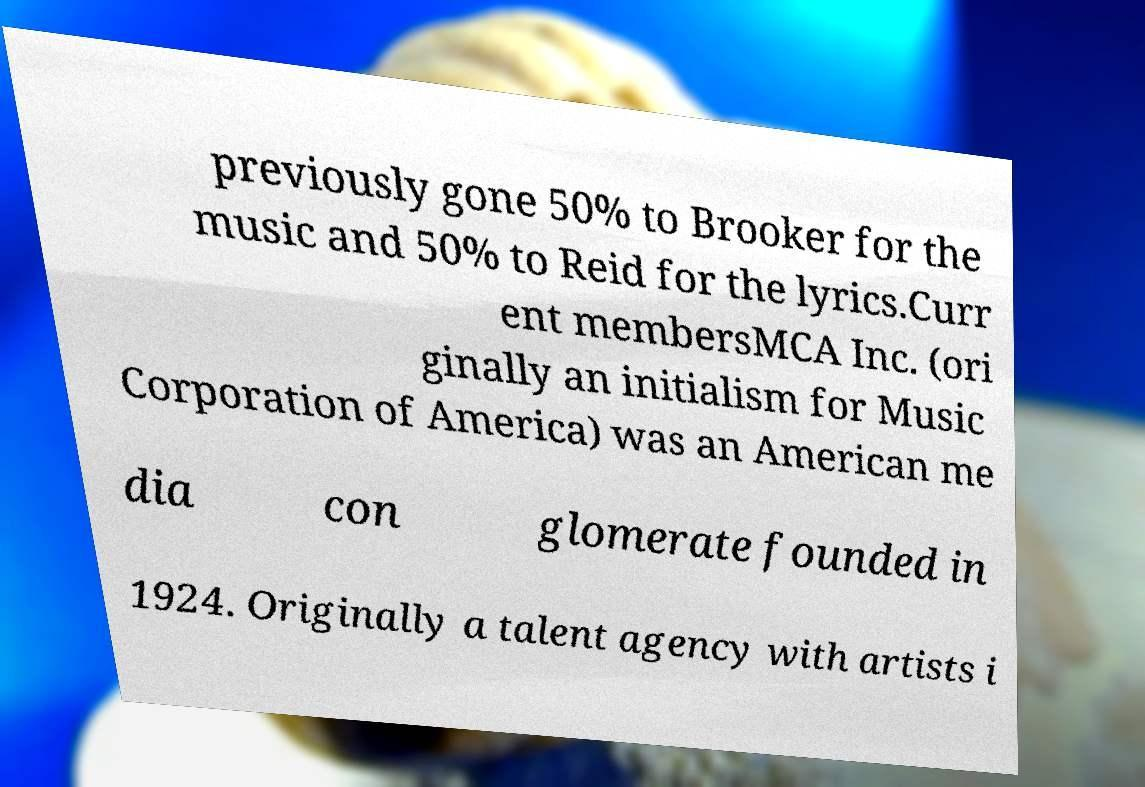I need the written content from this picture converted into text. Can you do that? previously gone 50% to Brooker for the music and 50% to Reid for the lyrics.Curr ent membersMCA Inc. (ori ginally an initialism for Music Corporation of America) was an American me dia con glomerate founded in 1924. Originally a talent agency with artists i 